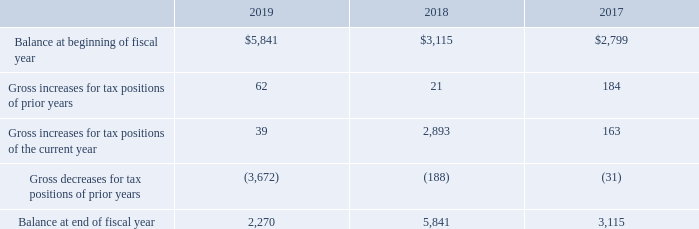The following is a reconciliation of the beginning and ending amounts of unrecognized income tax benefits (in thousands):
The amount of unrecognized tax benefits that, if recognized, would impact the effective tax rate is $ 1.5 million and $4.6 million for the fiscal years ended September 28, 2019 and September 29, 2018, respectively.
The Company recognizes accrued interest and penalties related to unrecognized tax benefits in income tax expense. The total accrued penalties and net accrued interest with respect to income taxes was approximately $0.2 million for each of the fiscal years ended September 28, 2019, September 29, 2018 and September 30, 2017. The Company recognized less than $0.1 million of expense for accrued penalties and net accrued interest in the Consolidated Statements of Comprehensive Income for each of the fiscal years ended September 28, 2019, September 29, 2018 and September 30, 2017.
Which years does the table provide information for the beginning and ending amounts of unrecognized income tax benefits? 2019, 2018, 2017. What was the amount of Gross increases for tax positions of prior years in 2019?
Answer scale should be: thousand. 62. What was the Balance at end of fiscal year in 2017?
Answer scale should be: thousand. 3,115. How many years did Gross increases for tax positions of the current year exceed $1,000 thousand? 2018
Answer: 1. What was the change in the Gross increases for tax positions of prior years between 2018 and 2019? 62-21
Answer: 41. What was the percentage change in the balance at end of fiscal year between 2018 and 2019?
Answer scale should be: percent. (2,270-5,841)/5,841
Answer: -61.14. 